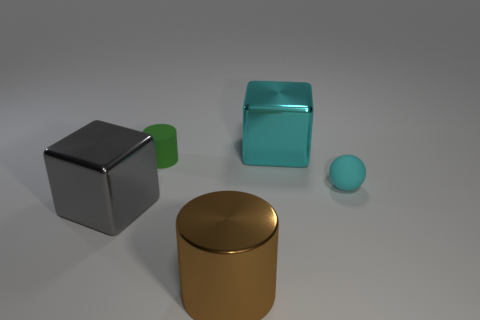Add 3 small balls. How many objects exist? 8 Subtract all blocks. How many objects are left? 3 Add 5 metallic cylinders. How many metallic cylinders are left? 6 Add 5 metallic cubes. How many metallic cubes exist? 7 Subtract 0 cyan cylinders. How many objects are left? 5 Subtract all small cyan objects. Subtract all small green objects. How many objects are left? 3 